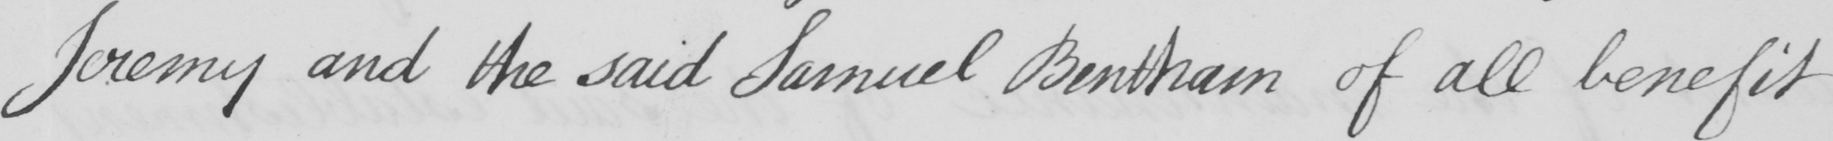Please provide the text content of this handwritten line. Jeremy and the said Samuel Bentham of all benefit 